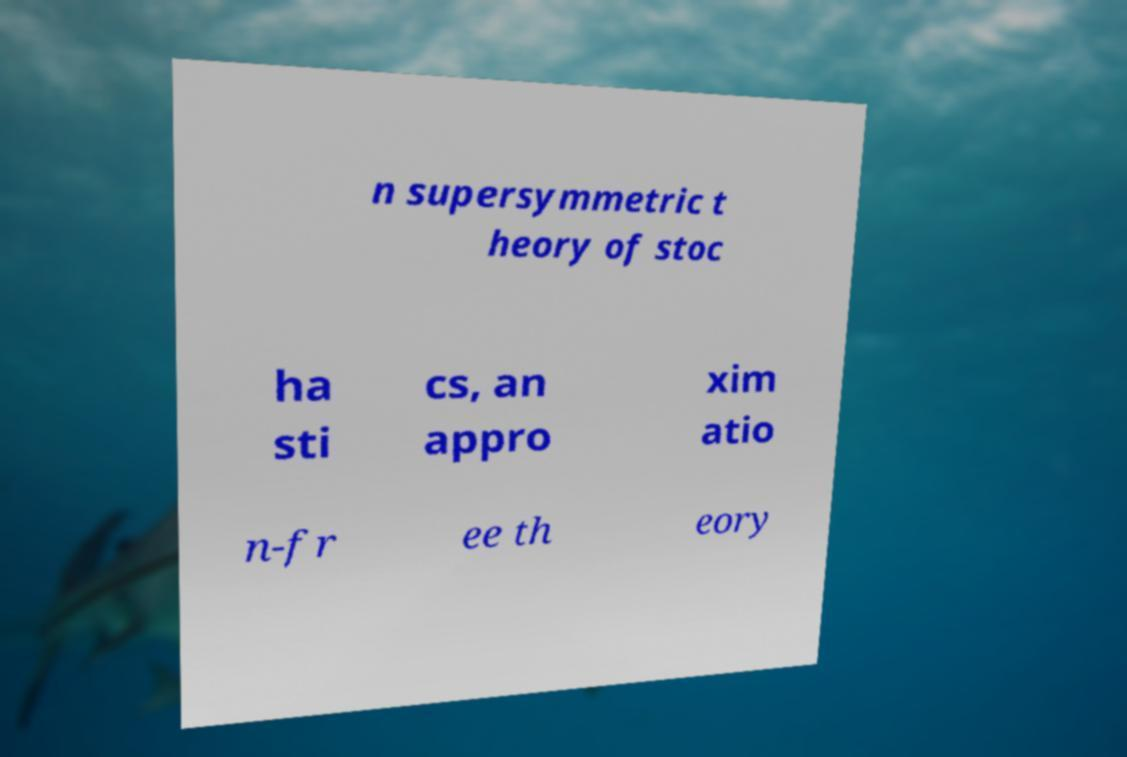Could you assist in decoding the text presented in this image and type it out clearly? n supersymmetric t heory of stoc ha sti cs, an appro xim atio n-fr ee th eory 